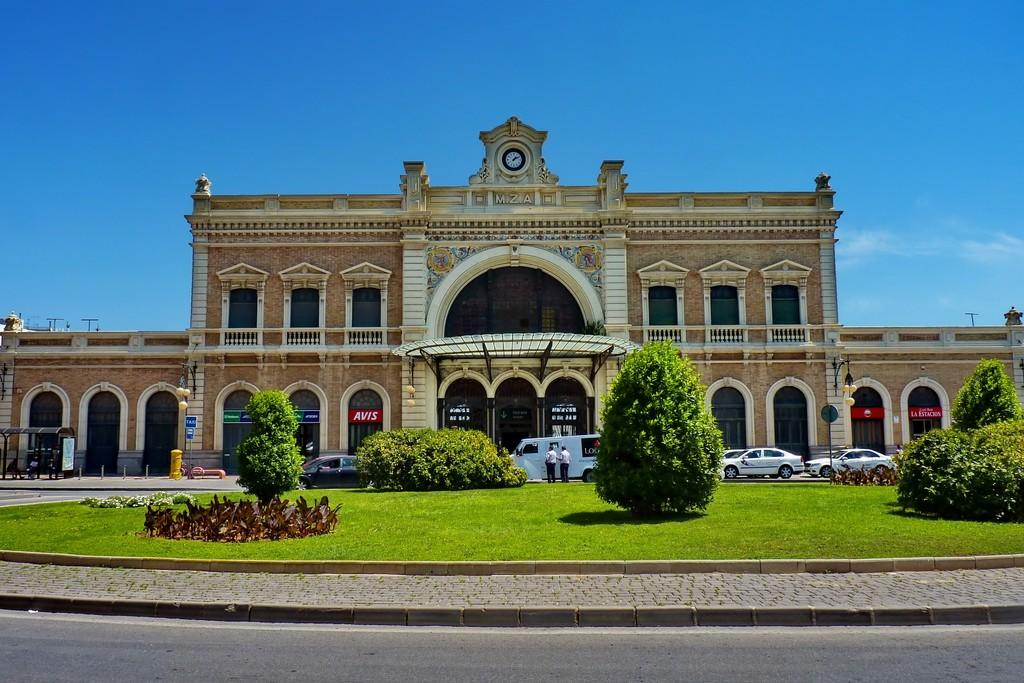<image>
Relay a brief, clear account of the picture shown. A huge building with the letters MZA on it has cars in front of it. 